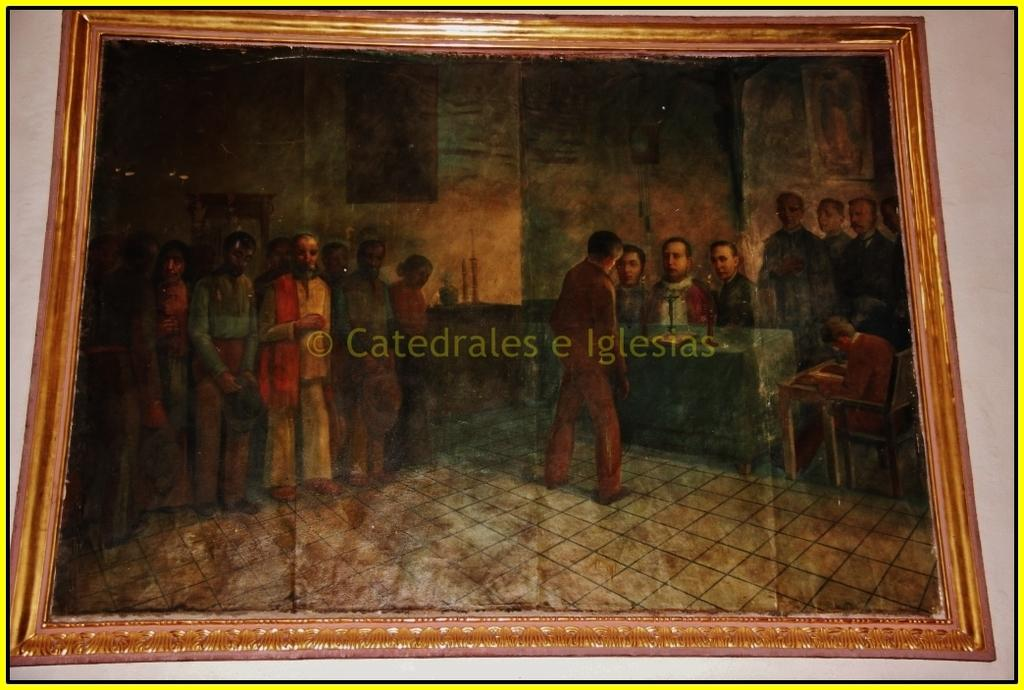What object is present in the image that typically holds a picture? There is a photo frame in the image. What can be seen inside the photo frame? The photo frame contains a depiction of persons. Are there any words or letters in the photo frame? Yes, there is text in the photo frame. What type of cap can be seen on the ice machine in the image? There is no ice machine or cap present in the image; it features a photo frame with a depiction of persons and text. 